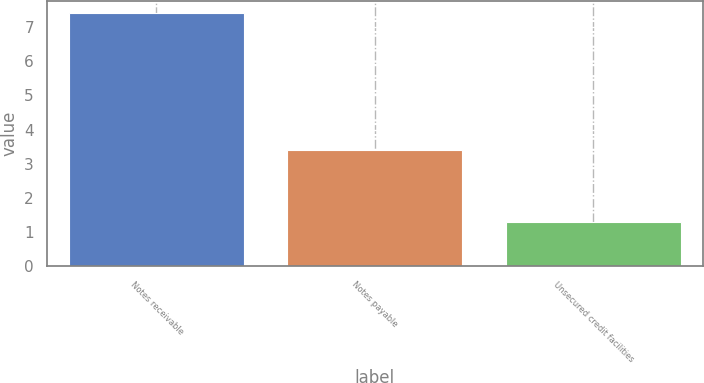<chart> <loc_0><loc_0><loc_500><loc_500><bar_chart><fcel>Notes receivable<fcel>Notes payable<fcel>Unsecured credit facilities<nl><fcel>7.4<fcel>3.4<fcel>1.3<nl></chart> 